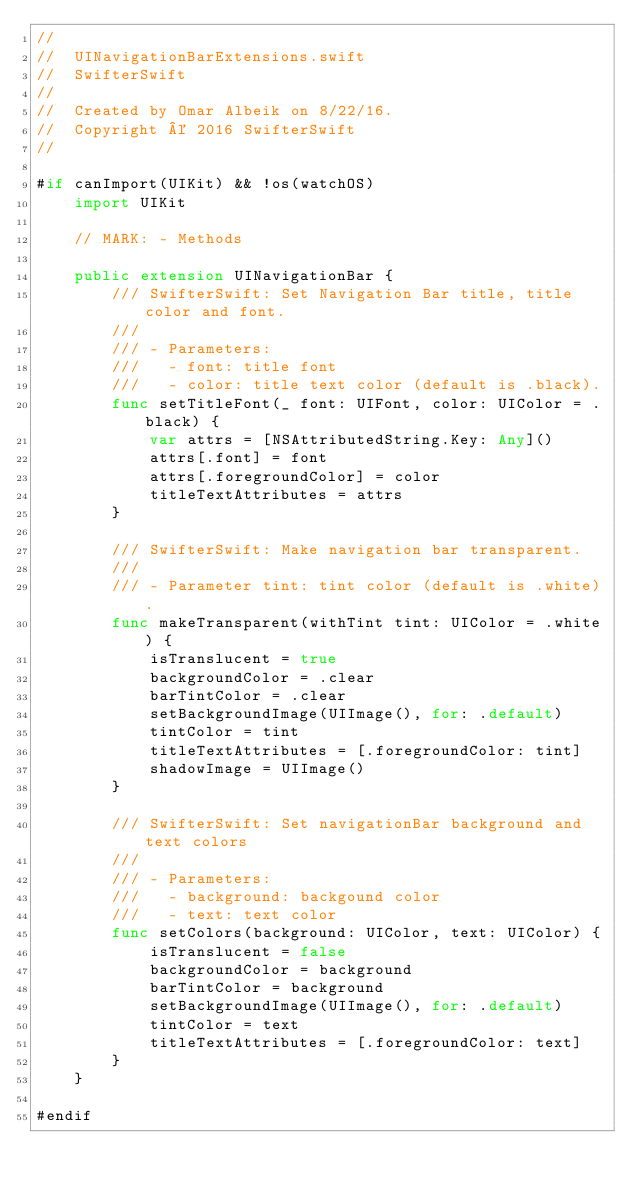<code> <loc_0><loc_0><loc_500><loc_500><_Swift_>//
//  UINavigationBarExtensions.swift
//  SwifterSwift
//
//  Created by Omar Albeik on 8/22/16.
//  Copyright © 2016 SwifterSwift
//

#if canImport(UIKit) && !os(watchOS)
    import UIKit

    // MARK: - Methods

    public extension UINavigationBar {
        /// SwifterSwift: Set Navigation Bar title, title color and font.
        ///
        /// - Parameters:
        ///   - font: title font
        ///   - color: title text color (default is .black).
        func setTitleFont(_ font: UIFont, color: UIColor = .black) {
            var attrs = [NSAttributedString.Key: Any]()
            attrs[.font] = font
            attrs[.foregroundColor] = color
            titleTextAttributes = attrs
        }

        /// SwifterSwift: Make navigation bar transparent.
        ///
        /// - Parameter tint: tint color (default is .white).
        func makeTransparent(withTint tint: UIColor = .white) {
            isTranslucent = true
            backgroundColor = .clear
            barTintColor = .clear
            setBackgroundImage(UIImage(), for: .default)
            tintColor = tint
            titleTextAttributes = [.foregroundColor: tint]
            shadowImage = UIImage()
        }

        /// SwifterSwift: Set navigationBar background and text colors
        ///
        /// - Parameters:
        ///   - background: backgound color
        ///   - text: text color
        func setColors(background: UIColor, text: UIColor) {
            isTranslucent = false
            backgroundColor = background
            barTintColor = background
            setBackgroundImage(UIImage(), for: .default)
            tintColor = text
            titleTextAttributes = [.foregroundColor: text]
        }
    }

#endif
</code> 